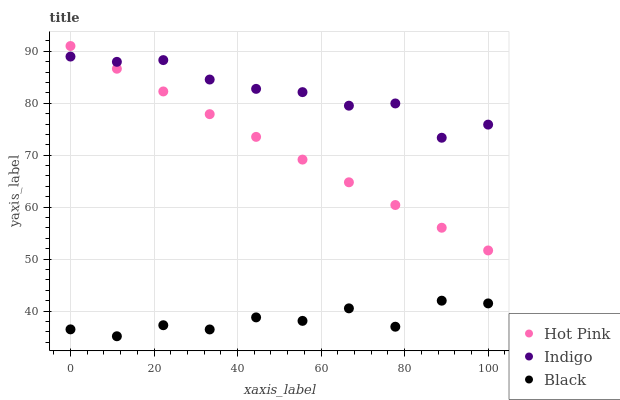Does Black have the minimum area under the curve?
Answer yes or no. Yes. Does Indigo have the maximum area under the curve?
Answer yes or no. Yes. Does Hot Pink have the minimum area under the curve?
Answer yes or no. No. Does Hot Pink have the maximum area under the curve?
Answer yes or no. No. Is Hot Pink the smoothest?
Answer yes or no. Yes. Is Black the roughest?
Answer yes or no. Yes. Is Indigo the smoothest?
Answer yes or no. No. Is Indigo the roughest?
Answer yes or no. No. Does Black have the lowest value?
Answer yes or no. Yes. Does Hot Pink have the lowest value?
Answer yes or no. No. Does Hot Pink have the highest value?
Answer yes or no. Yes. Does Indigo have the highest value?
Answer yes or no. No. Is Black less than Hot Pink?
Answer yes or no. Yes. Is Hot Pink greater than Black?
Answer yes or no. Yes. Does Indigo intersect Hot Pink?
Answer yes or no. Yes. Is Indigo less than Hot Pink?
Answer yes or no. No. Is Indigo greater than Hot Pink?
Answer yes or no. No. Does Black intersect Hot Pink?
Answer yes or no. No. 